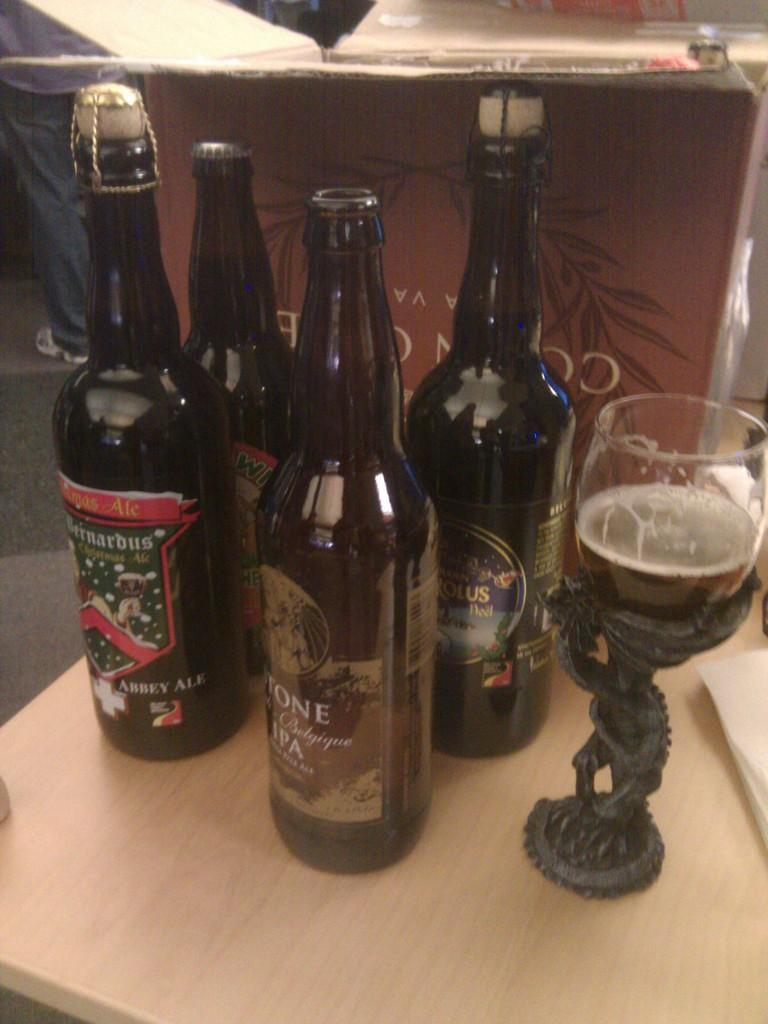What type of objects can be seen on the stand in the image? There are bottles and a glass on the stand in the image. Where is the stand located? The stand is on a table in the image. Can you describe the human presence in the image? There is a partial part of a human in the image. What is located behind the bottles on the stand? There is a box behind the bottles in the image. What type of leaf can be seen growing out of the glass in the image? There is no leaf growing out of the glass in the image; it contains a liquid. --- Facts: 1. There is a person in the image. 2. The person is wearing a hat. 3. The person is holding a book. 4. The person is sitting on a chair. 5. There is a table next to the person. Absurd Topics: elephant, piano, ocean Conversation: What is the main subject in the image? The main subject in the image is a person. What is the person wearing? The person is wearing a hat. What is the person holding? The person is holding a book. What is the person's posture in the image? The person is sitting on a chair. What is located next to the person? A: There is a table next to the person. Reasoning: Let's think step by step in order to ${produce the conversation}. We start by identifying the main subject of the image, which is a person. Next, we describe the person's attire, specifically the hat they are wearing. Then, we observe the actions of the person, noting that they are holding a book. After that, we describe the person's posture, which is sitting on a chair. Finally, we describe the surrounding environment, which includes a table next to the person. Absurd Question/Answer: Can you hear the sound of the ocean waves crashing in the image? There is no reference to an ocean or any sounds in the image, so it's not possible to determine if ocean waves can be heard. 